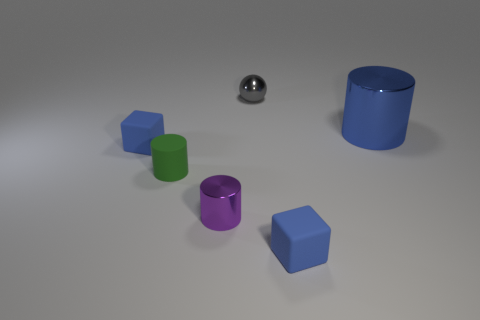There is a small green object in front of the blue metallic cylinder; what material is it?
Offer a terse response. Rubber. What is the size of the blue shiny object that is the same shape as the small purple metal object?
Provide a succinct answer. Large. What number of tiny green objects are the same material as the tiny gray object?
Provide a short and direct response. 0. How many things have the same color as the large metal cylinder?
Keep it short and to the point. 2. What number of things are metal things that are behind the large object or blue objects that are to the left of the large blue object?
Offer a terse response. 3. Is the number of tiny gray spheres to the left of the small green thing less than the number of tiny gray balls?
Your answer should be very brief. Yes. Is there a blue cylinder of the same size as the purple metal object?
Keep it short and to the point. No. What color is the small metallic sphere?
Provide a succinct answer. Gray. Do the gray metal sphere and the rubber cylinder have the same size?
Your answer should be compact. Yes. How many objects are either large metallic cylinders or large gray blocks?
Give a very brief answer. 1. 